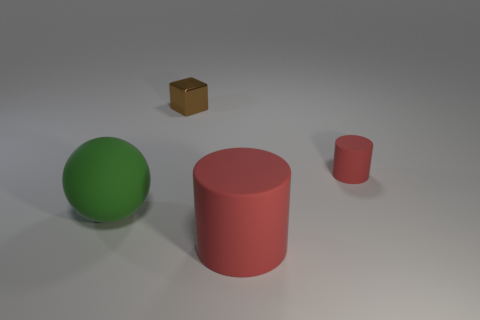Add 2 big purple cubes. How many objects exist? 6 Subtract all cubes. How many objects are left? 3 Subtract 0 purple balls. How many objects are left? 4 Subtract 1 cylinders. How many cylinders are left? 1 Subtract all purple blocks. Subtract all red balls. How many blocks are left? 1 Subtract all cyan balls. How many cyan blocks are left? 0 Subtract all large red matte cylinders. Subtract all gray matte objects. How many objects are left? 3 Add 1 red matte things. How many red matte things are left? 3 Add 3 small yellow objects. How many small yellow objects exist? 3 